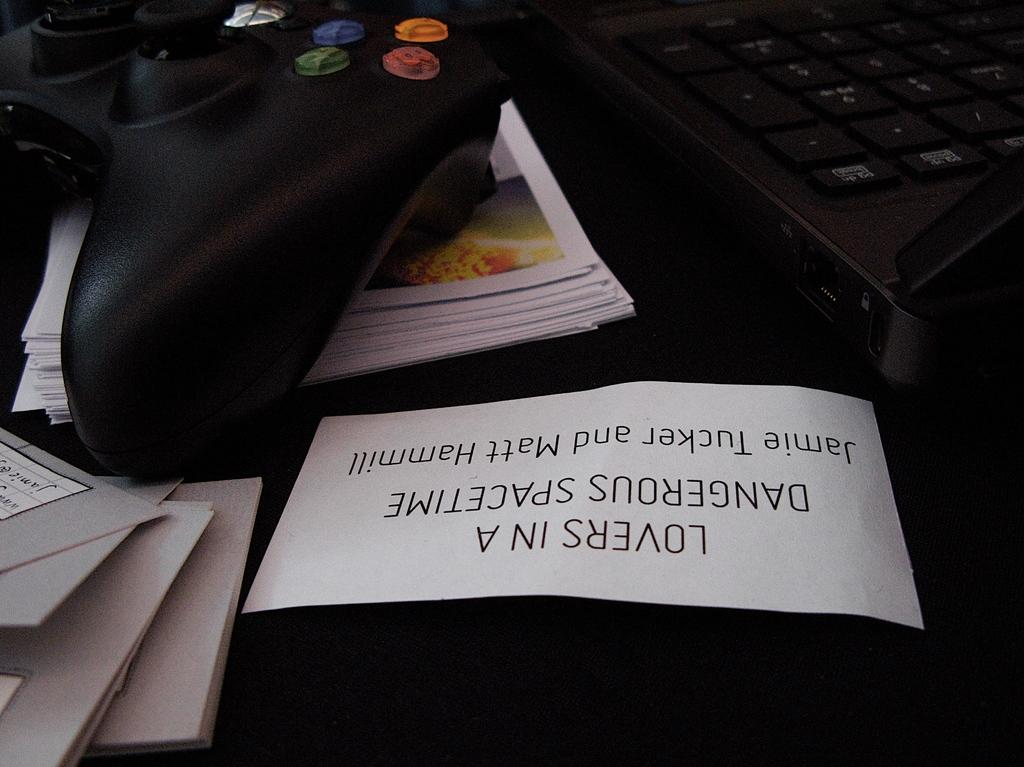<image>
Give a short and clear explanation of the subsequent image. White label that says "Loves In a Dangerous Spacetime" next to an Xbox controller. 